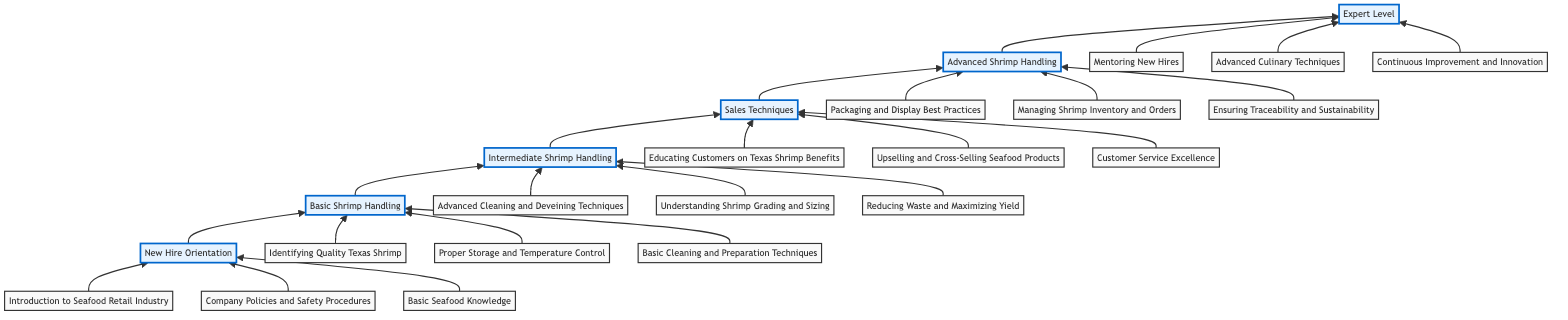What is the highest level in the training program? The diagram shows the flow from "New Hire Orientation" at the bottom to "Expert Level" at the top, indicating "Expert Level" is the highest stage.
Answer: Expert Level How many training program levels are there in total? Counting the levels listed, there are six distinct stages shown in the diagram, which are "New Hire Orientation," "Basic Shrimp Handling," "Intermediate Shrimp Handling," "Sales Techniques," "Advanced Shrimp Handling," and "Expert Level."
Answer: 6 What element is included in "Sales Techniques"? The diagram lists multiple elements under each level, and for "Sales Techniques," one of the elements is "Educating Customers on Texas Shrimp Benefits."
Answer: Educating Customers on Texas Shrimp Benefits Which level follows "Basic Shrimp Handling"? The flowchart diagram indicates a progression from "Basic Shrimp Handling" upward to the next level, which is "Intermediate Shrimp Handling."
Answer: Intermediate Shrimp Handling What is the last task for the "Expert Level"? The diagram shows three tasks associated with "Expert Level," and the last listed task is "Continuous Improvement and Innovation."
Answer: Continuous Improvement and Innovation How many elements are listed under "Advanced Shrimp Handling"? Under "Advanced Shrimp Handling," the diagram specifies three elements, which are "Packaging and Display Best Practices," "Managing Shrimp Inventory and Orders," and "Ensuring Traceability and Sustainability."
Answer: 3 Which level requires "Advanced Cleaning and Deveining Techniques"? Based on the upward flow illustrated in the diagram, "Advanced Cleaning and Deveining Techniques" is listed under the level "Intermediate Shrimp Handling."
Answer: Intermediate Shrimp Handling What is the starting point of the training program? The diagram clearly shows that the training program starts from "New Hire Orientation," as it is the first level before progressing upward.
Answer: New Hire Orientation What do all the elements in "Basic Shrimp Handling" focus on? The elements in "Basic Shrimp Handling" revolve around fundamental aspects of shrimp processing; they include identifying, storing, and preparing shrimp.
Answer: Identifying, storing, and preparing shrimp 